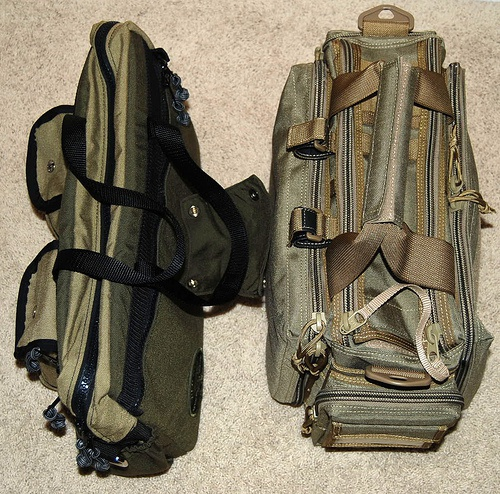Describe the objects in this image and their specific colors. I can see suitcase in tan, gray, and black tones and backpack in tan, black, darkgreen, olive, and gray tones in this image. 